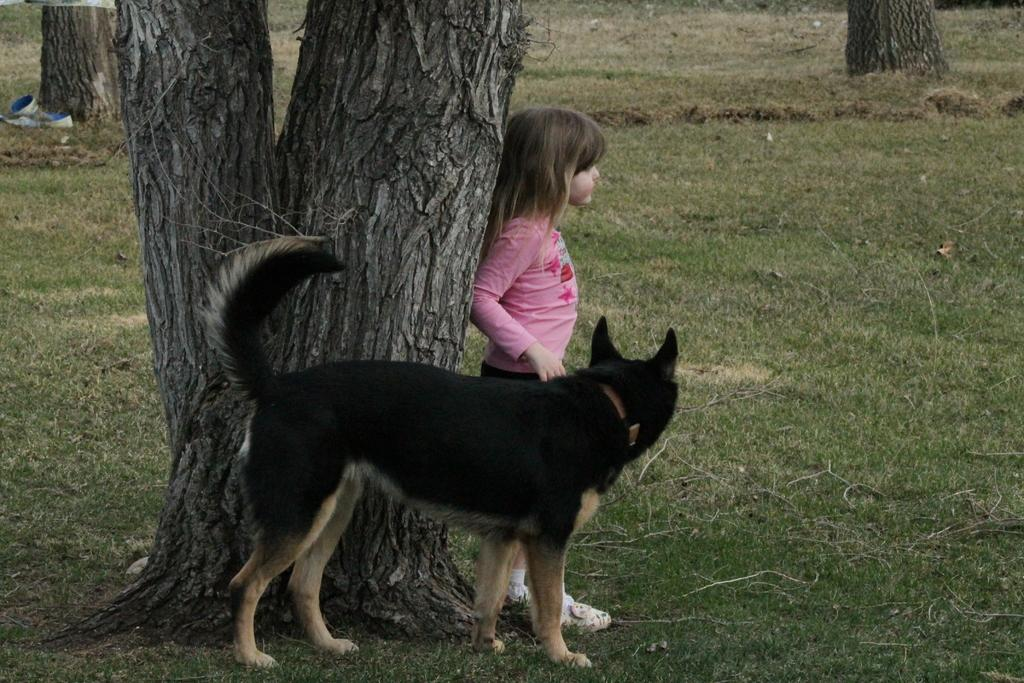Who is present in the image? There is a girl in the image. What is the girl doing in the image? The girl is standing beside a tree. What other living creature is in the image? There is a dog in the image. What is the color of the grass in the image? The grass is green in color. What type of cloth is being used to make bread in the image? There is no cloth or bread present in the image. How many earths can be seen in the image? There is only one Earth visible in the image, as it is a photograph taken on our planet. 